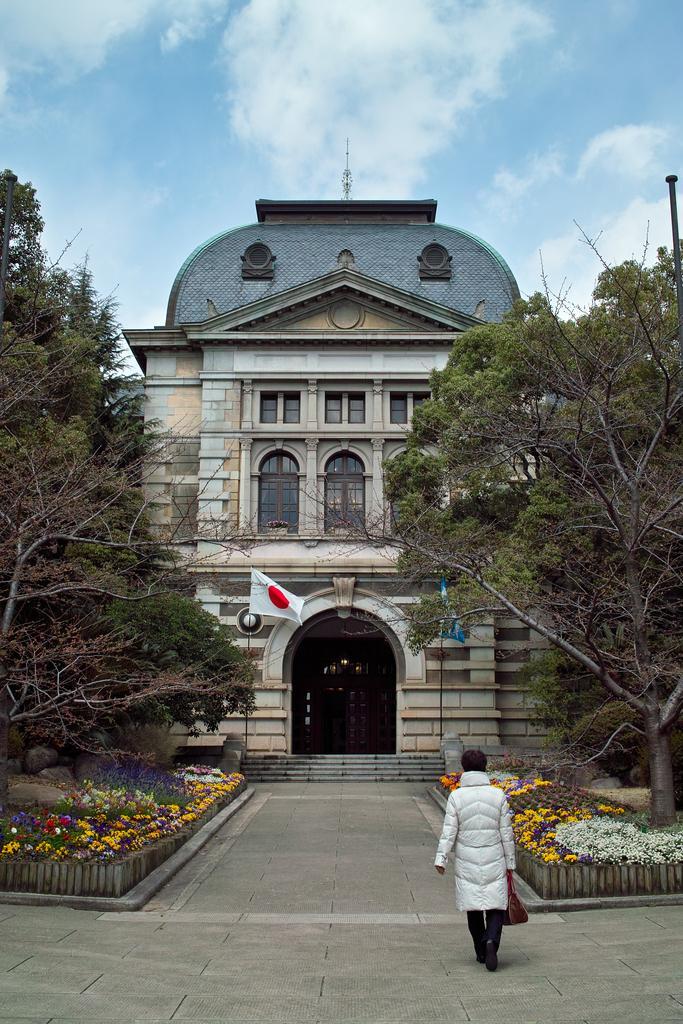Could you give a brief overview of what you see in this image? In this image there is a building. On the right and left side of the image there are trees, flowers and plants and there is a lady walking and she is holding a bag. In the background there is the sky. 